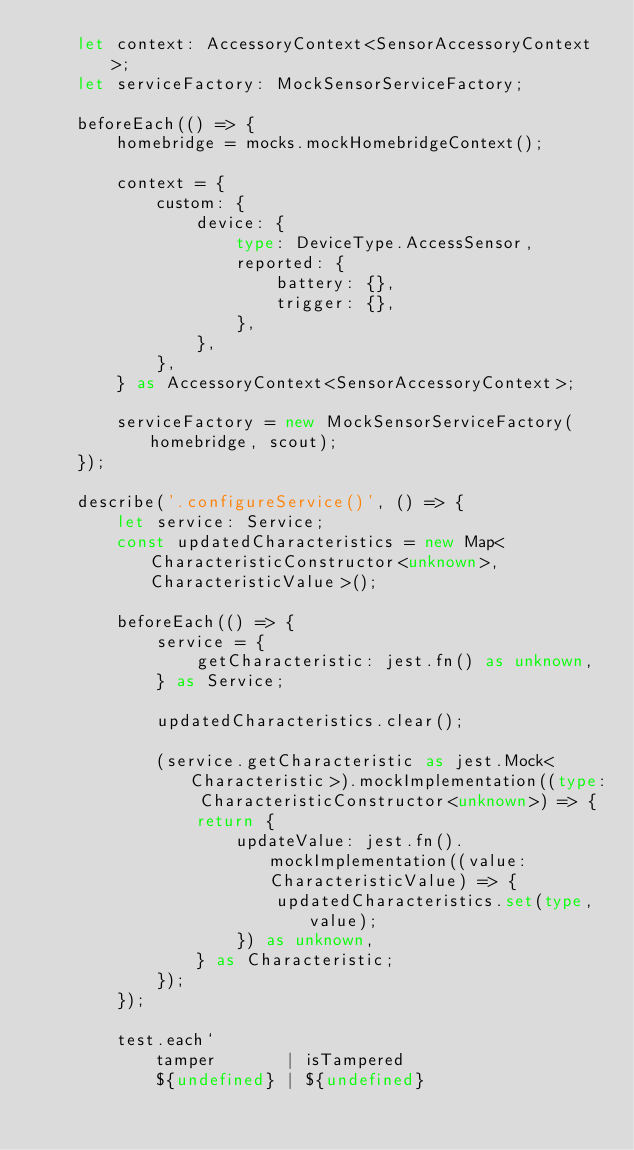Convert code to text. <code><loc_0><loc_0><loc_500><loc_500><_TypeScript_>    let context: AccessoryContext<SensorAccessoryContext>;
    let serviceFactory: MockSensorServiceFactory;

    beforeEach(() => {
        homebridge = mocks.mockHomebridgeContext();

        context = {
            custom: {
                device: {
                    type: DeviceType.AccessSensor,
                    reported: {
                        battery: {},
                        trigger: {},
                    },
                },
            },
        } as AccessoryContext<SensorAccessoryContext>;

        serviceFactory = new MockSensorServiceFactory(homebridge, scout);
    });

    describe('.configureService()', () => {
        let service: Service;
        const updatedCharacteristics = new Map<CharacteristicConstructor<unknown>, CharacteristicValue>();

        beforeEach(() => {
            service = {
                getCharacteristic: jest.fn() as unknown,
            } as Service;

            updatedCharacteristics.clear();

            (service.getCharacteristic as jest.Mock<Characteristic>).mockImplementation((type: CharacteristicConstructor<unknown>) => {
                return {
                    updateValue: jest.fn().mockImplementation((value: CharacteristicValue) => {
                        updatedCharacteristics.set(type, value);
                    }) as unknown,
                } as Characteristic;
            });
        });

        test.each`
            tamper       | isTampered
            ${undefined} | ${undefined}</code> 